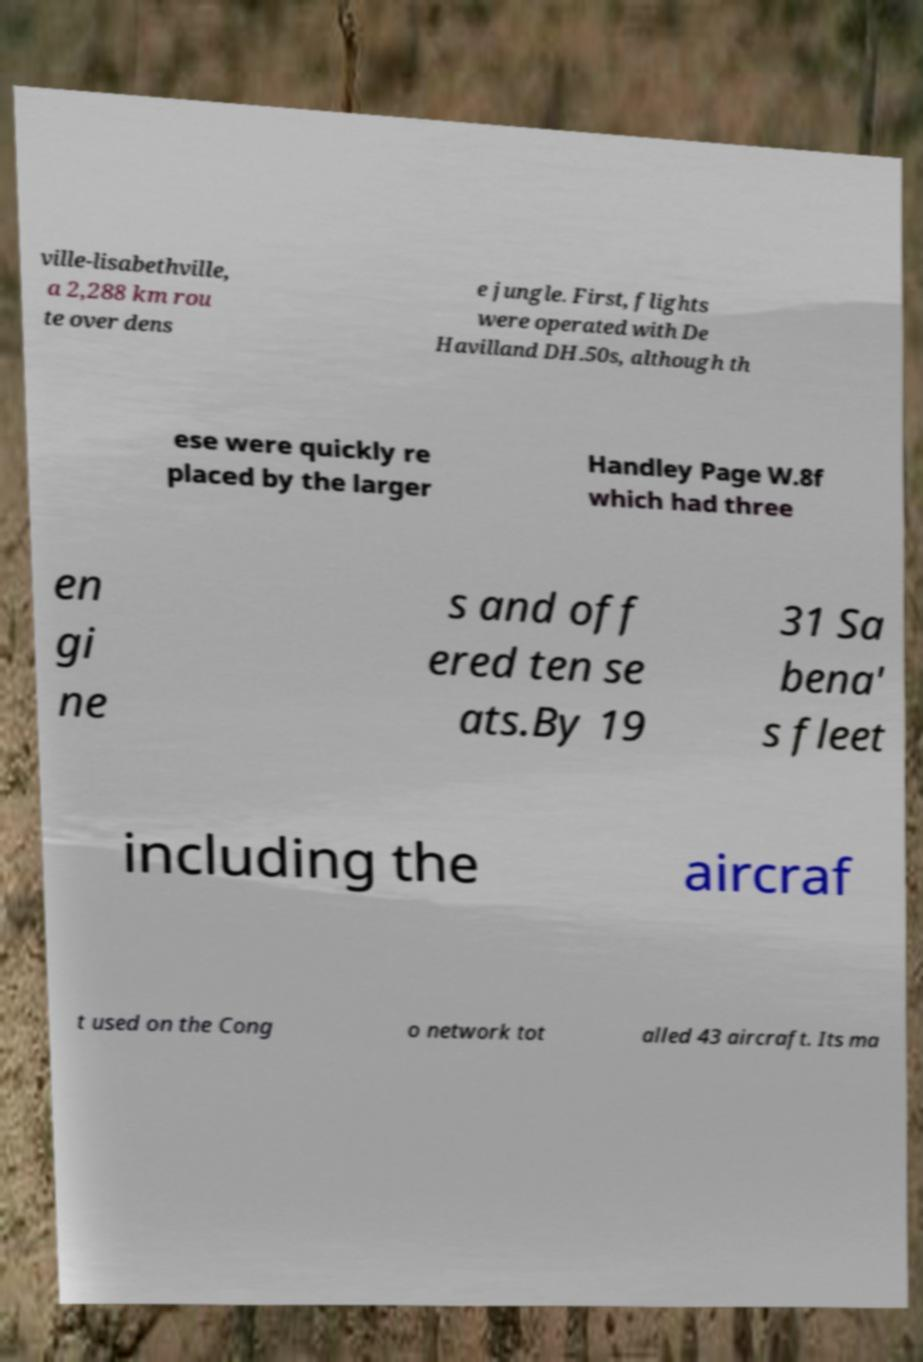For documentation purposes, I need the text within this image transcribed. Could you provide that? ville-lisabethville, a 2,288 km rou te over dens e jungle. First, flights were operated with De Havilland DH.50s, although th ese were quickly re placed by the larger Handley Page W.8f which had three en gi ne s and off ered ten se ats.By 19 31 Sa bena' s fleet including the aircraf t used on the Cong o network tot alled 43 aircraft. Its ma 